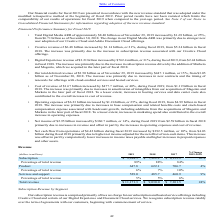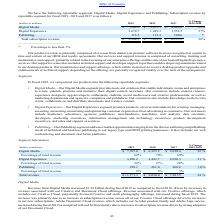Looking at Adobe Systems's financial data, please calculate: What is the percentage change in publishing between 2018 and 2019? To answer this question, I need to perform calculations using the financial data. The calculation is: (115.5-115.2)/115.2, which equals 0.26 (percentage). This is based on the information: "Publishing 115.5 115.2 100.6 * Publishing 115.5 115.2 100.6 *..." The key data points involved are: 115.2, 115.5. Also, can you calculate: What was the percentage change in total subscription revenue for 2018-2017?  To answer this question, I need to perform calculations using the financial data. The calculation is: (7,922.2 - 6,133.9)/6,133.9 , which equals 29.15 (percentage). This is based on the information: "Subscription $ 9,994.5 $ 7,922.2 $ 6,133.9 26% Subscription $ 9,994.5 $ 7,922.2 $ 6,133.9 26%..." The key data points involved are: 6,133.9, 7,922.2. Also, can you calculate: What is the sum of digital media and digital experience revenue in 2017? Based on the calculation: $4,480.8+$1,552.5, the result is 6033.3 (in millions). This is based on the information: "Digital Media $ 7,208.3 $ 5,857.7 $ 4,480.8 23% Digital Experience 2,670.7 1,949.3 1,552.5 37%..." The key data points involved are: 1,552.5, 4,480.8. Also, What does their subscription revenue mainly comprise of? fees we charge for our subscription and hosted service offerings including Creative Cloud and certain of our Digital Experience and Document Cloud services. The document states: "ur subscription revenue is comprised primarily of fees we charge for our subscription and hosted service offerings including Creative Cloud and certai..." Also, What does their product revenue comprise of? revenue from distinct on-premise software licenses recognized at a point in time and certain of our OEM and royalty agreements. The document states: "Our product revenue is primarily comprised of revenue from distinct on-premise software licenses recognized at a point in time and certain of our OEM ..." Also, What does their services and support revenue comprise of? consulting, training and maintenance and support, primarily related to the licensing of our enterprise offerings and the sale of our hosted Digital Experience services.. The document states: ". Our services and support revenue is comprised of consulting, training and maintenance and support, primarily related to the licensing of our enterpr..." 